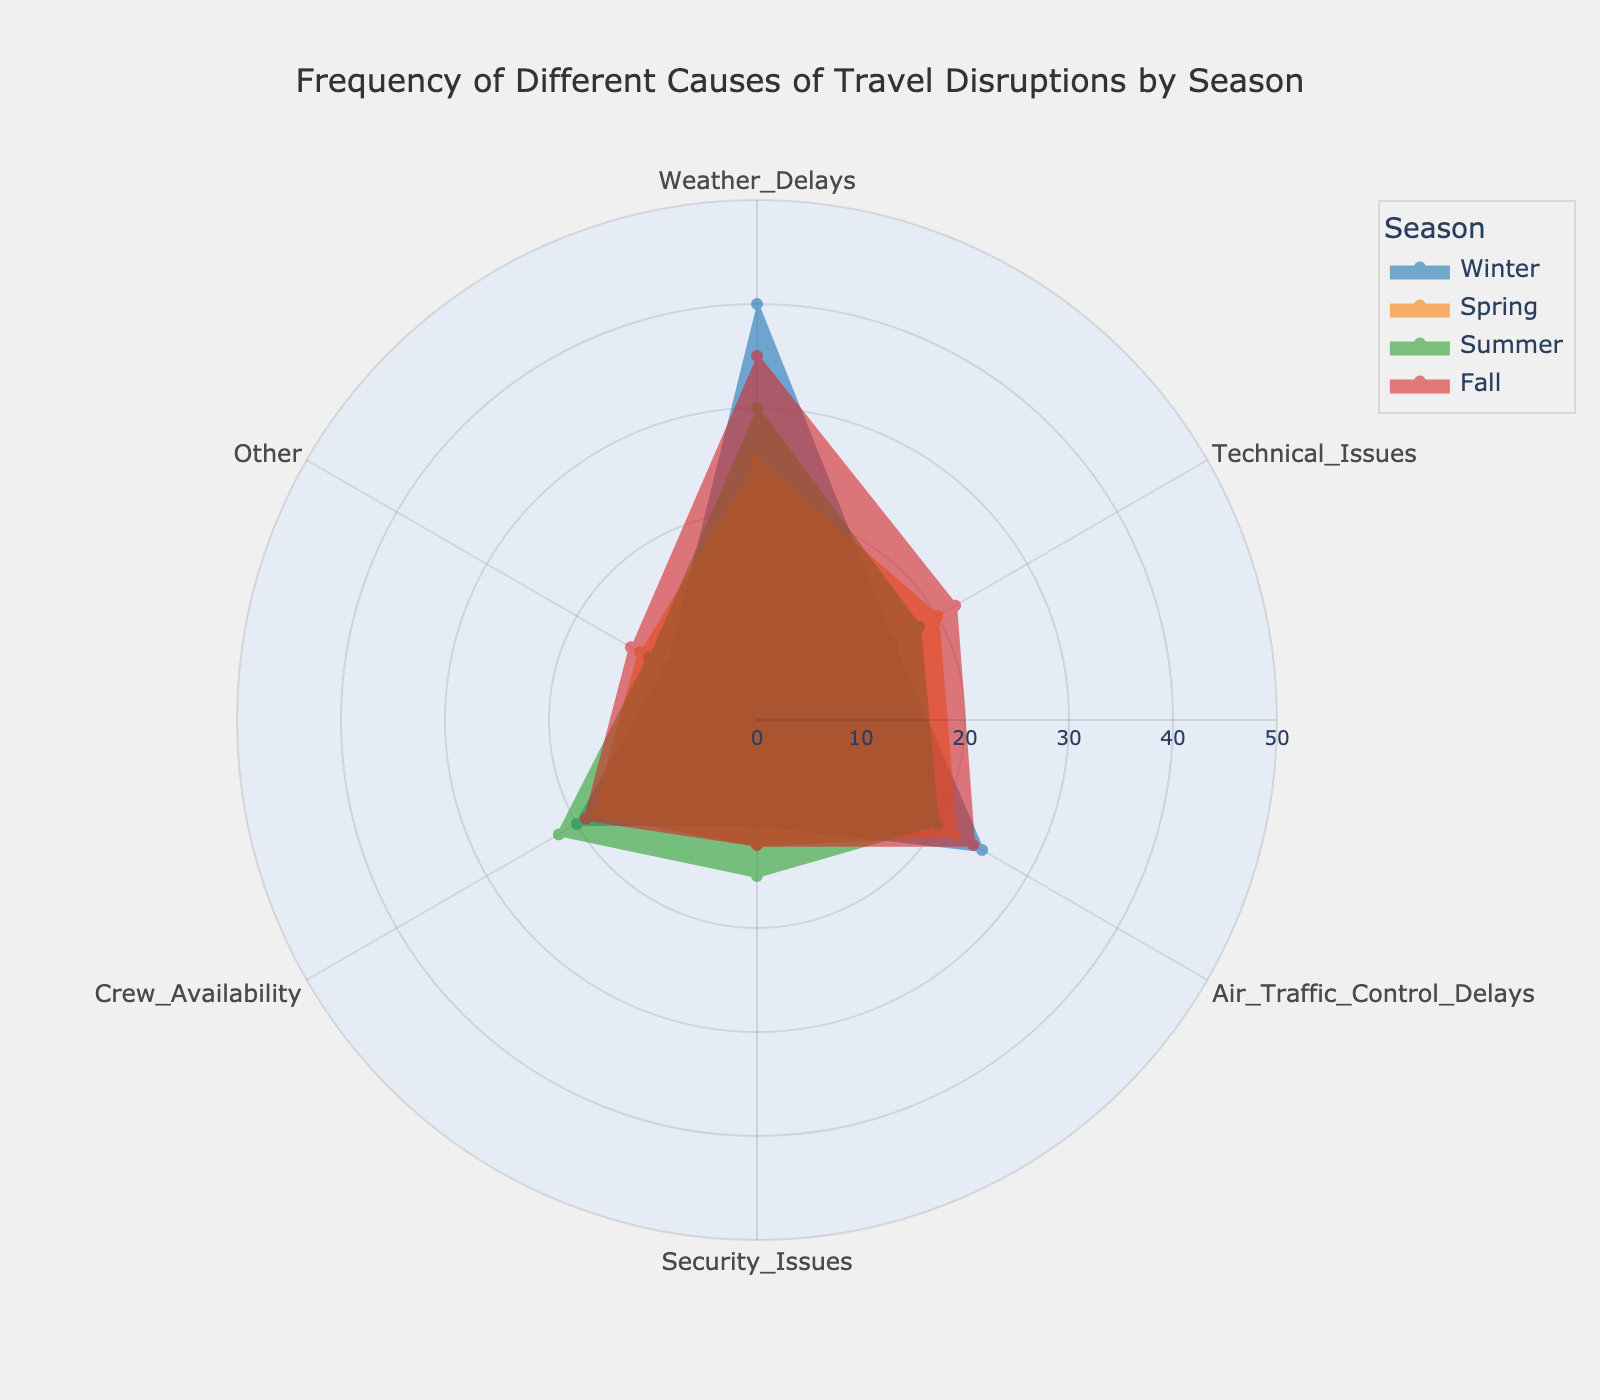What is the most frequent cause of travel disruption in Winter? By observing the plot, we see the sector for "Weather Delays" extends the furthest out in Winter, indicating it has the highest frequency.
Answer: Weather Delays Which season has the highest frequency of security issues? Looking for the "Security Issues" sectors, the Summer sector extends the furthest out compared to Spring, Winter, and Fall.
Answer: Summer How does the frequency of crew availability issues in Fall compare to Summer? The plot shows crew availability in Summer reaches 22 units, while in Fall, it reaches 19 units. Thus, Summer has a higher frequency than Fall.
Answer: Summer has a higher frequency Which cause has the least frequent disruptions in Spring? In the Spring sectors, "Technical Issues" has the shortest extension, indicating it is the lowest.
Answer: Technical Issues What is the total frequency of technical issues across all seasons? Summing the frequencies for technical issues: Winter (15) + Spring (20) + Summer (18) + Fall (22) = 75.
Answer: 75 Which season shows the smallest variation across all causes of disruptions? Comparing each season's sector lengths, Spring sectors appear more uniform compared to others, indicating lesser variation.
Answer: Spring Are weather delays more frequent in Fall or Winter? Looking at the sectors for weather delays, Winter extends to 40 units while Fall extends to 35 units. Thus, weather delays are more frequent in Winter.
Answer: Winter What is the average frequency of air traffic control delays throughout the year? Summing the frequencies for air traffic control delays: Winter (25) + Spring (22) + Summer (20) + Fall (24) = 91. Average is 91/4 = 22.75.
Answer: 22.75 